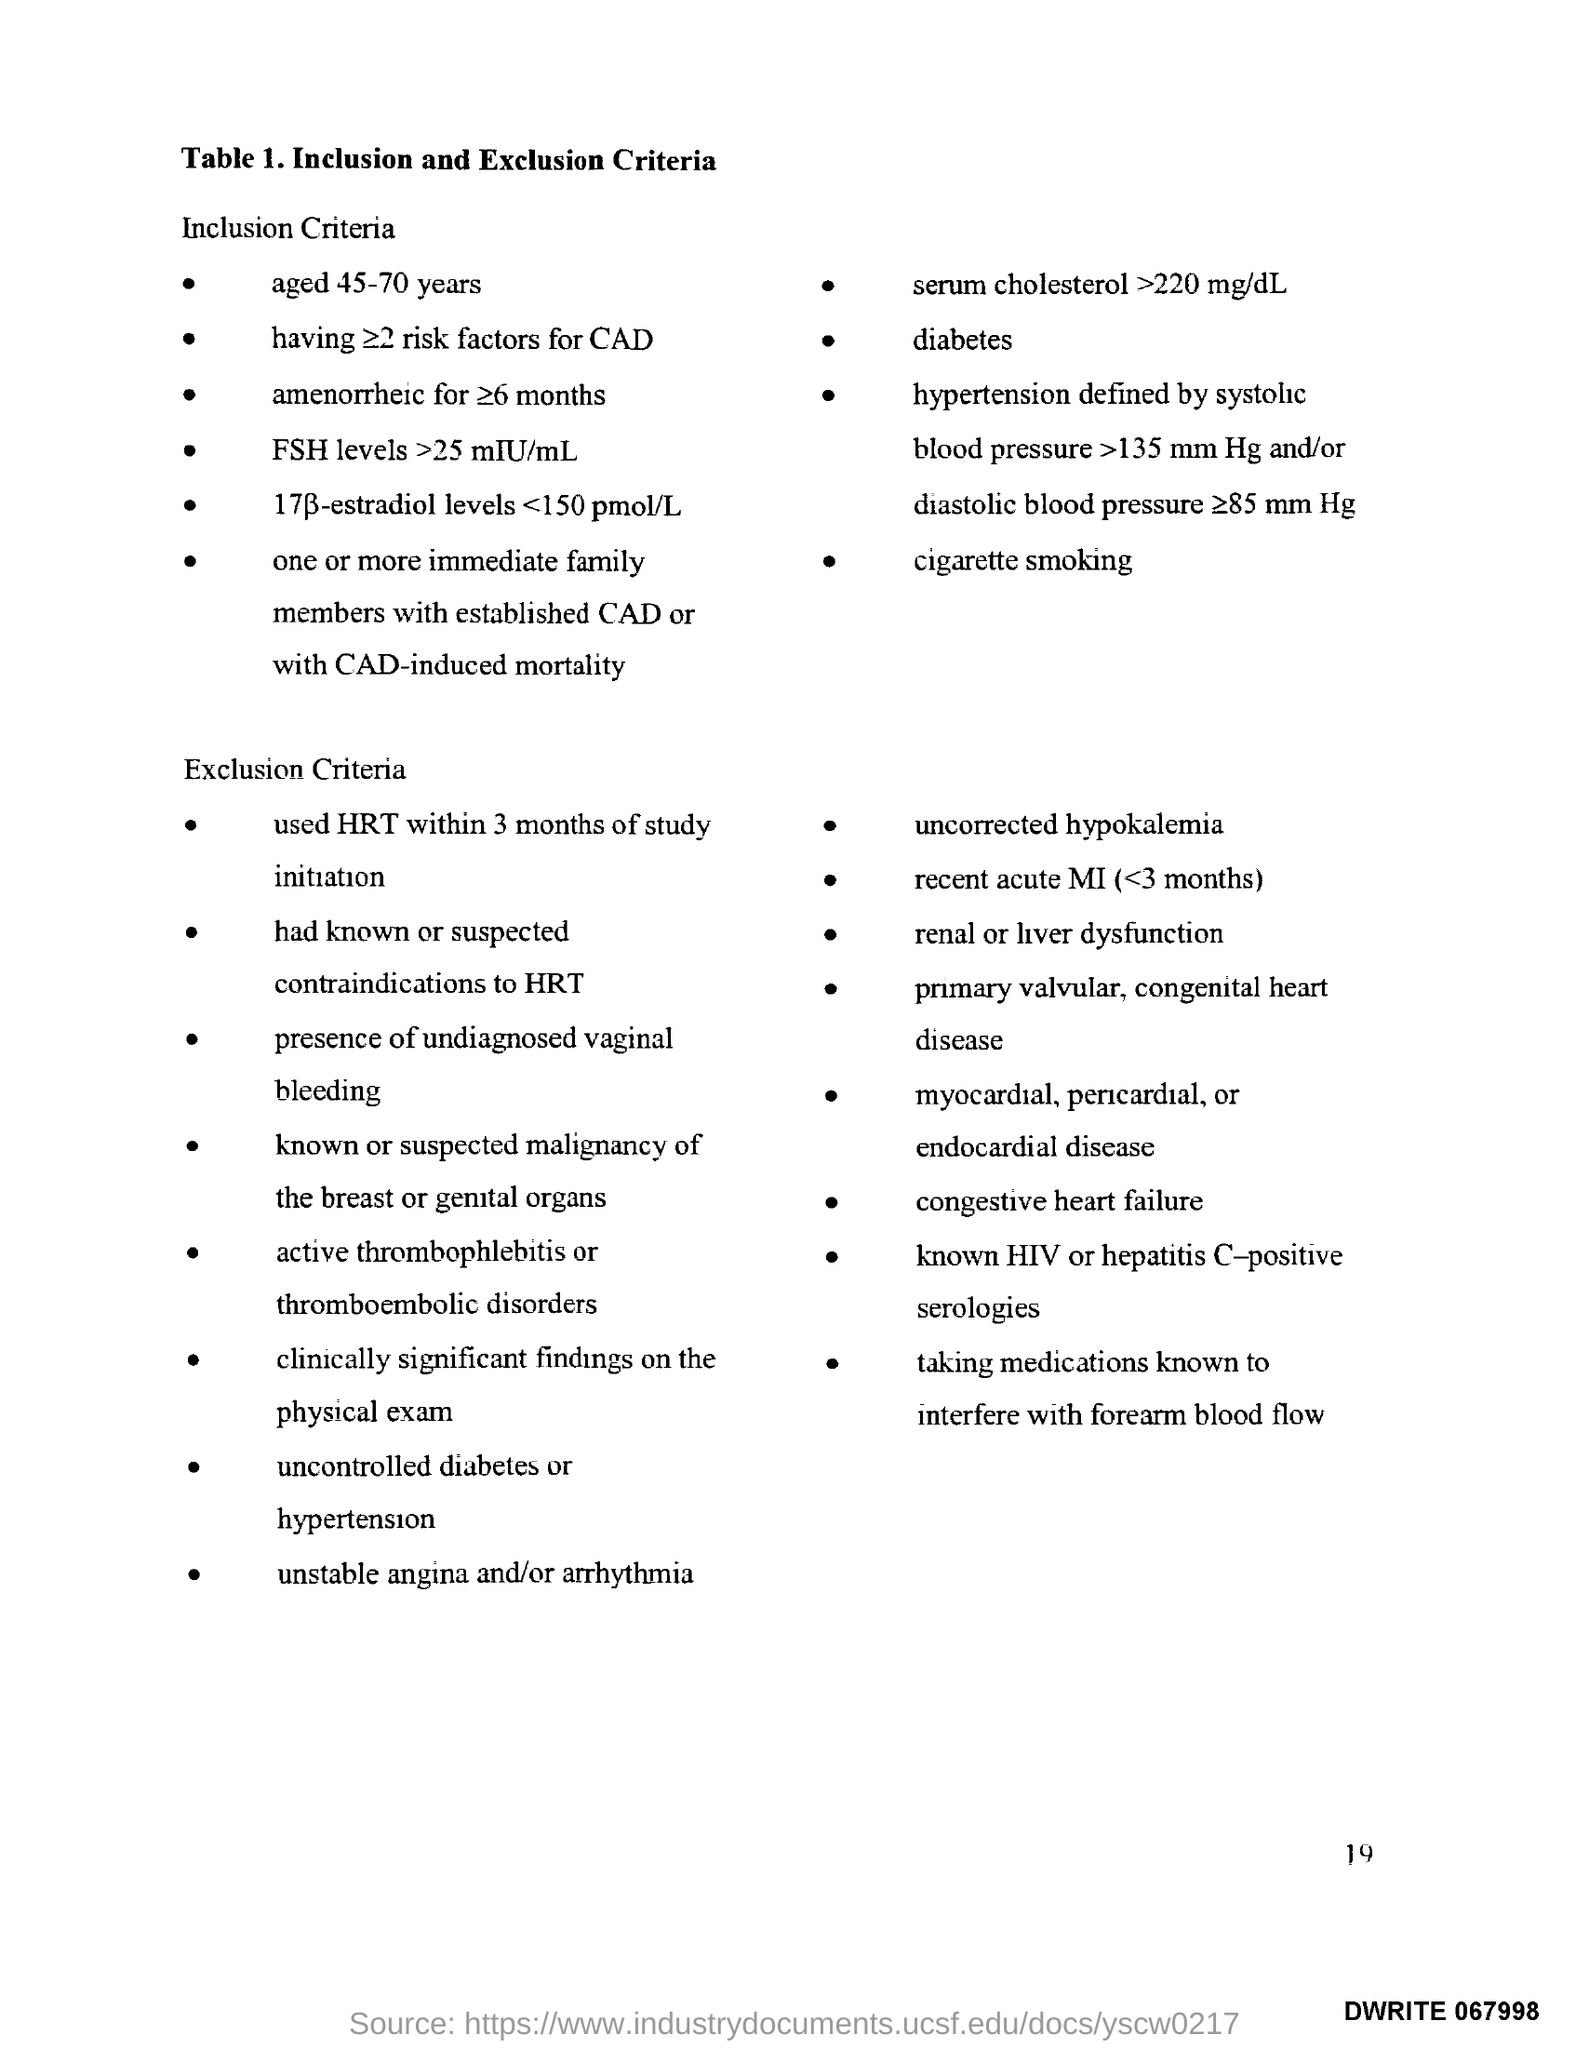What is the Page Number?
Give a very brief answer. 19. 